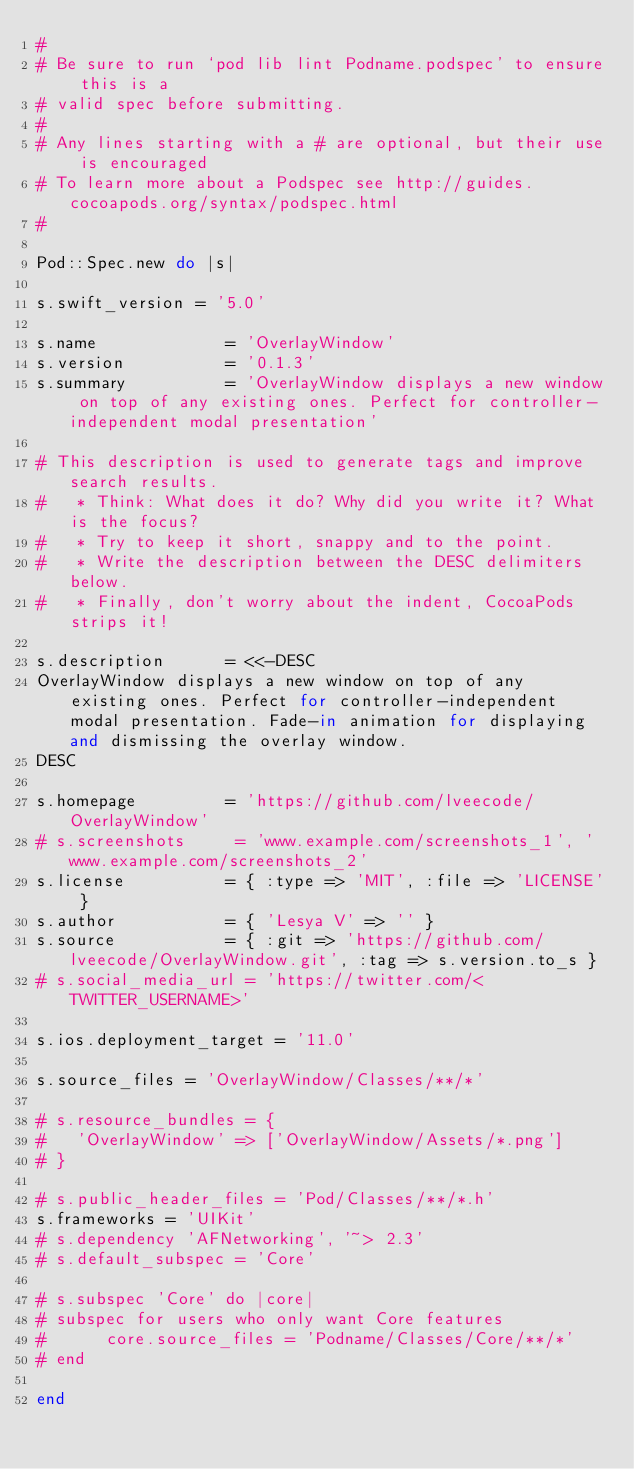Convert code to text. <code><loc_0><loc_0><loc_500><loc_500><_Ruby_>#
# Be sure to run `pod lib lint Podname.podspec' to ensure this is a
# valid spec before submitting.
#
# Any lines starting with a # are optional, but their use is encouraged
# To learn more about a Podspec see http://guides.cocoapods.org/syntax/podspec.html
#

Pod::Spec.new do |s|

s.swift_version = '5.0'

s.name             = 'OverlayWindow'
s.version          = '0.1.3'
s.summary          = 'OverlayWindow displays a new window on top of any existing ones. Perfect for controller-independent modal presentation'

# This description is used to generate tags and improve search results.
#   * Think: What does it do? Why did you write it? What is the focus?
#   * Try to keep it short, snappy and to the point.
#   * Write the description between the DESC delimiters below.
#   * Finally, don't worry about the indent, CocoaPods strips it!

s.description      = <<-DESC
OverlayWindow displays a new window on top of any existing ones. Perfect for controller-independent modal presentation. Fade-in animation for displaying and dismissing the overlay window.
DESC

s.homepage         = 'https://github.com/lveecode/OverlayWindow'
# s.screenshots     = 'www.example.com/screenshots_1', 'www.example.com/screenshots_2'
s.license          = { :type => 'MIT', :file => 'LICENSE' }
s.author           = { 'Lesya V' => '' }
s.source           = { :git => 'https://github.com/lveecode/OverlayWindow.git', :tag => s.version.to_s }
# s.social_media_url = 'https://twitter.com/<TWITTER_USERNAME>'

s.ios.deployment_target = '11.0'

s.source_files = 'OverlayWindow/Classes/**/*'

# s.resource_bundles = {
#   'OverlayWindow' => ['OverlayWindow/Assets/*.png']
# }

# s.public_header_files = 'Pod/Classes/**/*.h'
s.frameworks = 'UIKit'
# s.dependency 'AFNetworking', '~> 2.3'
# s.default_subspec = 'Core'

# s.subspec 'Core' do |core|
# subspec for users who only want Core features
#      core.source_files = 'Podname/Classes/Core/**/*'
# end

end
</code> 